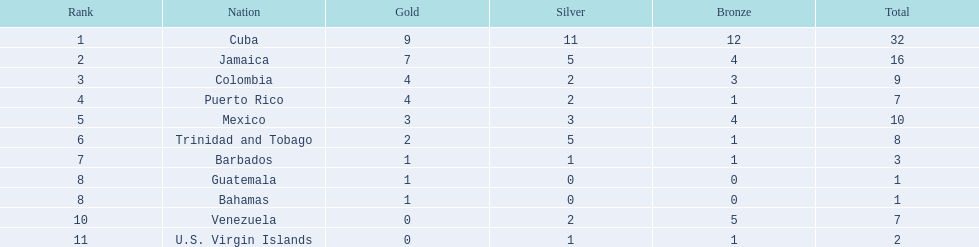Which states took part in the contests? Cuba, Jamaica, Colombia, Puerto Rico, Mexico, Trinidad and Tobago, Barbados, Guatemala, Bahamas, Venezuela, U.S. Virgin Islands. How many silver medals did they obtain? 11, 5, 2, 2, 3, 5, 1, 0, 0, 2, 1. Which group garnered the most silver? Cuba. 